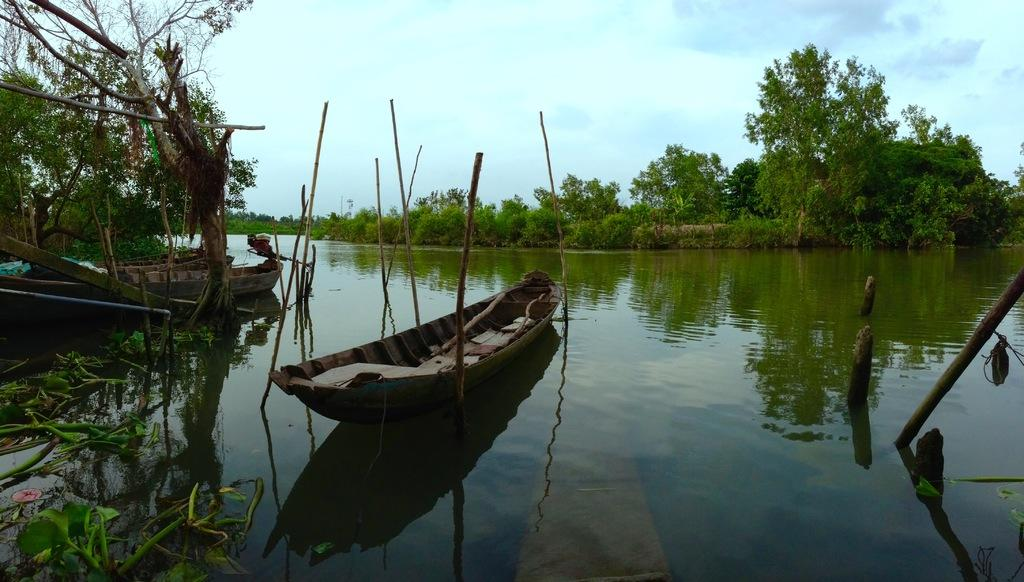What type of vehicles are in the water in the image? There are boats in the water in the image. What objects can be seen besides the boats in the image? There are wooden sticks visible in the image. What can be seen in the background of the image? There are trees and the sky visible in the background of the image. What type of yam is being used as a paddle for the boats in the image? There is no yam present in the image, and yams are not used as paddles for boats. 